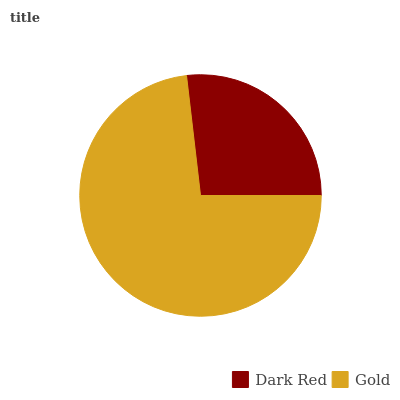Is Dark Red the minimum?
Answer yes or no. Yes. Is Gold the maximum?
Answer yes or no. Yes. Is Gold the minimum?
Answer yes or no. No. Is Gold greater than Dark Red?
Answer yes or no. Yes. Is Dark Red less than Gold?
Answer yes or no. Yes. Is Dark Red greater than Gold?
Answer yes or no. No. Is Gold less than Dark Red?
Answer yes or no. No. Is Gold the high median?
Answer yes or no. Yes. Is Dark Red the low median?
Answer yes or no. Yes. Is Dark Red the high median?
Answer yes or no. No. Is Gold the low median?
Answer yes or no. No. 